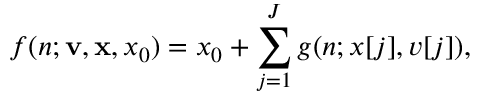Convert formula to latex. <formula><loc_0><loc_0><loc_500><loc_500>f ( n ; v , x , x _ { 0 } ) = x _ { 0 } + \sum _ { j = 1 } ^ { J } g ( n ; x [ j ] , v [ j ] ) ,</formula> 